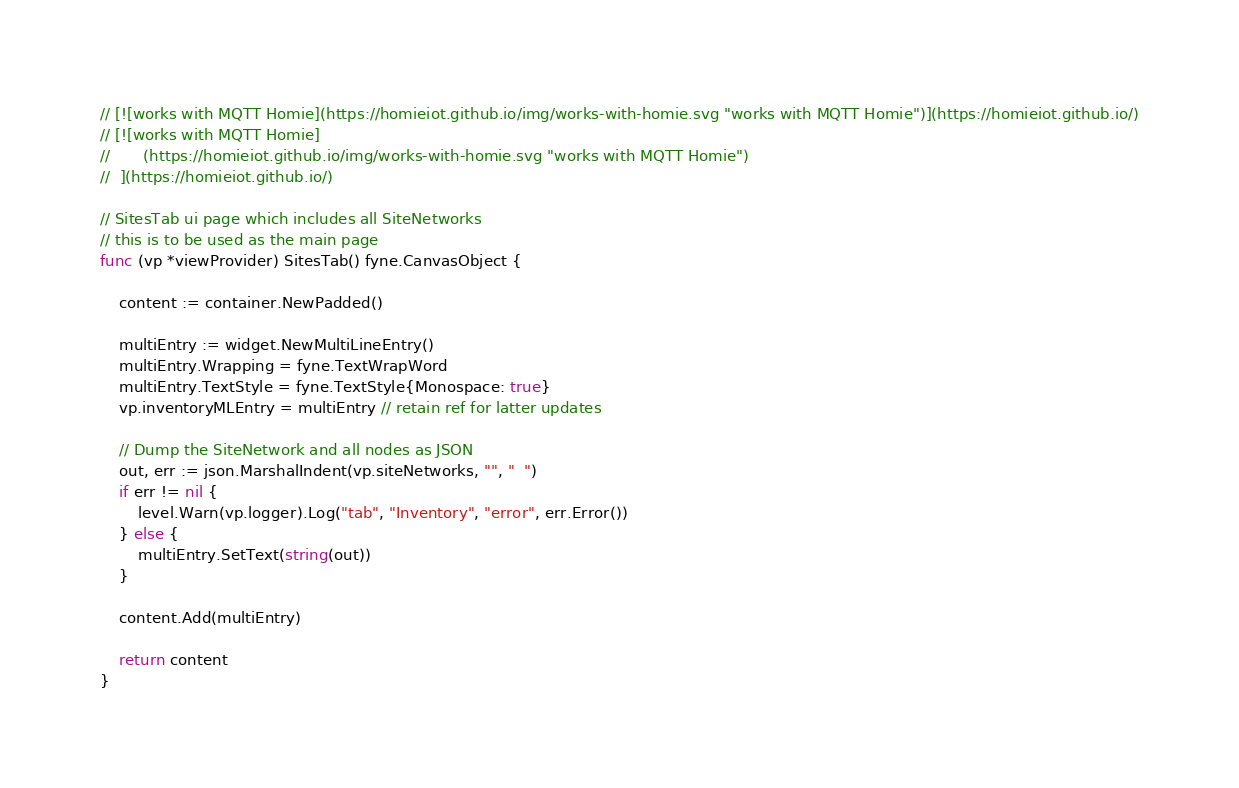Convert code to text. <code><loc_0><loc_0><loc_500><loc_500><_Go_>// [![works with MQTT Homie](https://homieiot.github.io/img/works-with-homie.svg "works with MQTT Homie")](https://homieiot.github.io/)
// [![works with MQTT Homie]
//       (https://homieiot.github.io/img/works-with-homie.svg "works with MQTT Homie")
//  ](https://homieiot.github.io/)

// SitesTab ui page which includes all SiteNetworks
// this is to be used as the main page
func (vp *viewProvider) SitesTab() fyne.CanvasObject {

	content := container.NewPadded()

	multiEntry := widget.NewMultiLineEntry()
	multiEntry.Wrapping = fyne.TextWrapWord
	multiEntry.TextStyle = fyne.TextStyle{Monospace: true}
	vp.inventoryMLEntry = multiEntry // retain ref for latter updates

	// Dump the SiteNetwork and all nodes as JSON
	out, err := json.MarshalIndent(vp.siteNetworks, "", "  ")
	if err != nil {
		level.Warn(vp.logger).Log("tab", "Inventory", "error", err.Error())
	} else {
		multiEntry.SetText(string(out))
	}

	content.Add(multiEntry)

	return content
}
</code> 